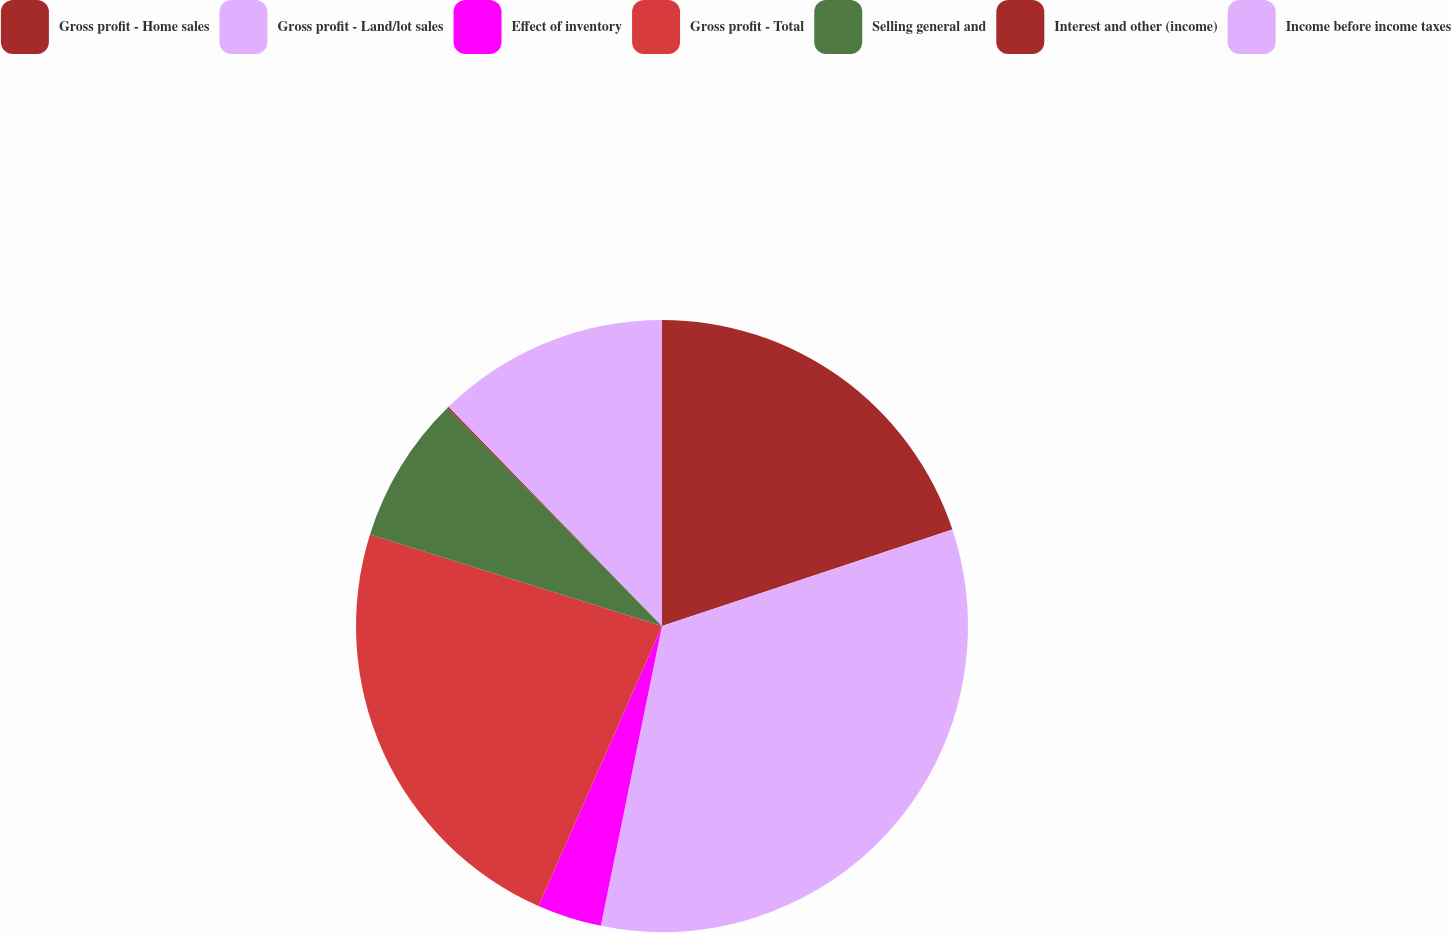<chart> <loc_0><loc_0><loc_500><loc_500><pie_chart><fcel>Gross profit - Home sales<fcel>Gross profit - Land/lot sales<fcel>Effect of inventory<fcel>Gross profit - Total<fcel>Selling general and<fcel>Interest and other (income)<fcel>Income before income taxes<nl><fcel>19.9%<fcel>33.31%<fcel>3.41%<fcel>23.22%<fcel>7.79%<fcel>0.09%<fcel>12.29%<nl></chart> 